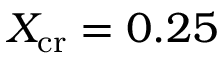<formula> <loc_0><loc_0><loc_500><loc_500>X _ { c r } = 0 . 2 5</formula> 